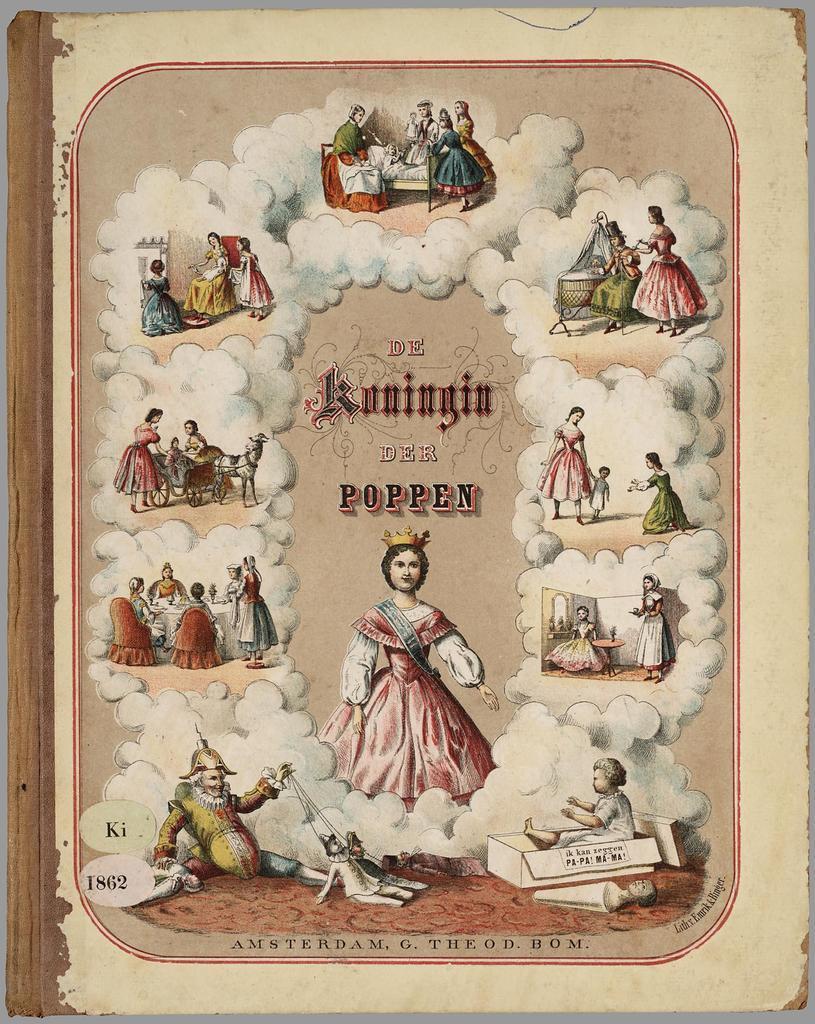Could you give a brief overview of what you see in this image? Here we can see poster, in this poster we can see persons. 